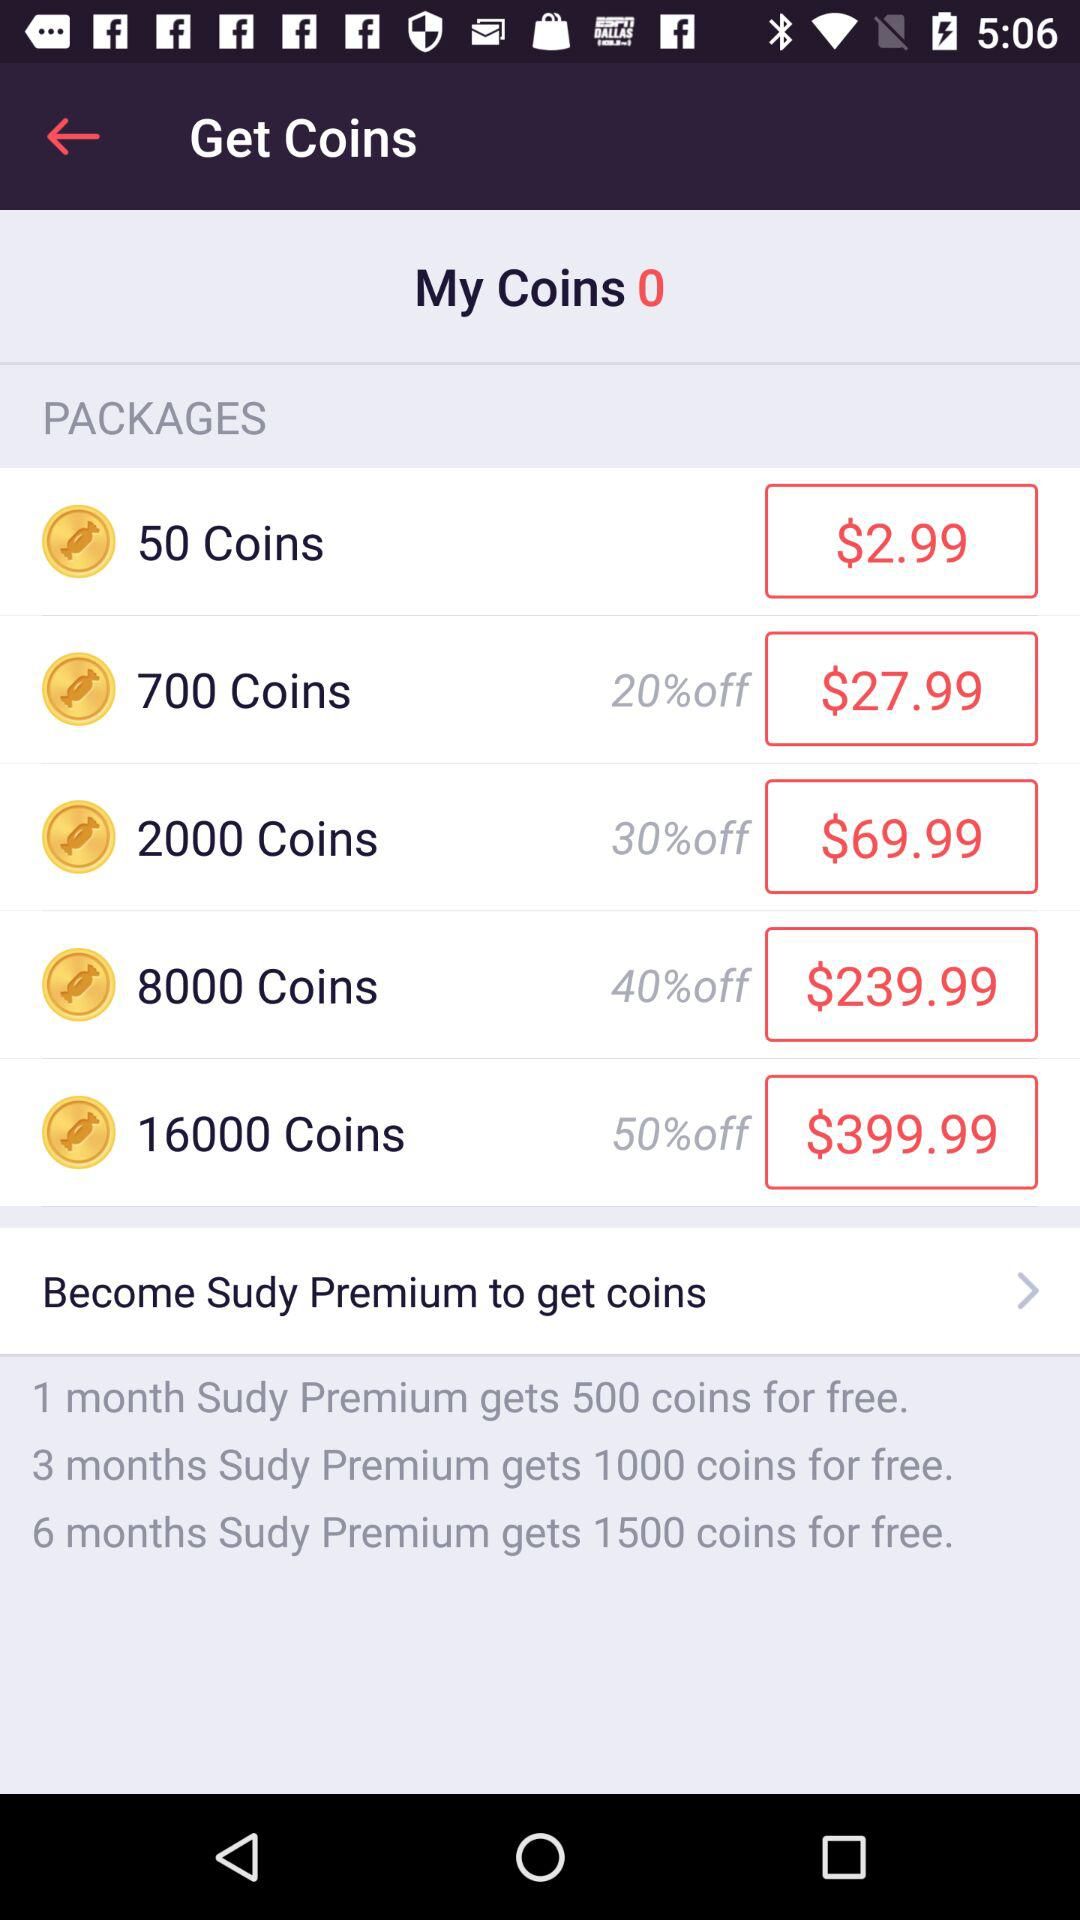What's the total count of coins in "My Coins"? The total count of coins is 0. 